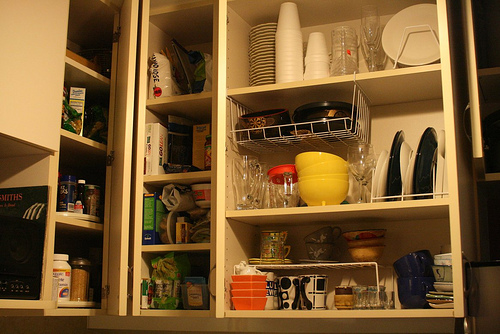<image>
Can you confirm if the box is on the shelf? Yes. Looking at the image, I can see the box is positioned on top of the shelf, with the shelf providing support. 